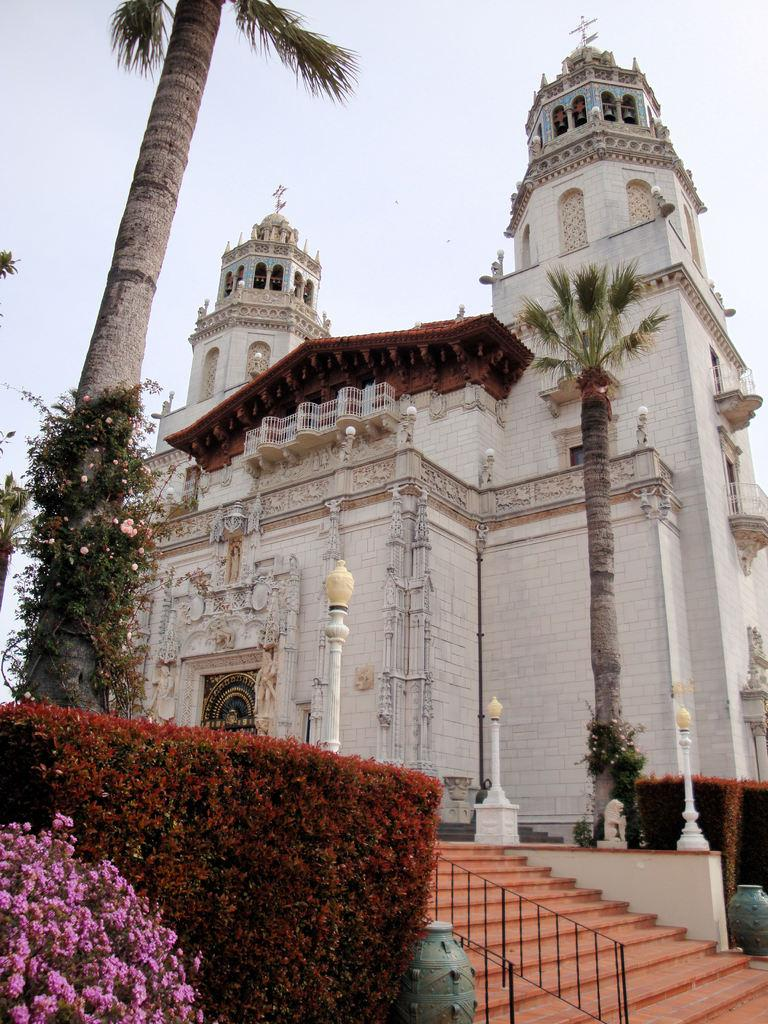What colors are the flowers in the image? The flowers in the image are in pink and maroon colors. What is the color of the building in the image? The building in the image is white. What structures are present for illumination in the image? There are light poles in the image. What architectural feature is present for accessibility in the image? There are stairs in the image. What part of the natural environment is visible in the image? The sky is visible in the image, and it appears to be white. How many offices are visible in the image? There is no office present in the image. Is there a playground visible in the image? There is no playground present in the image. 